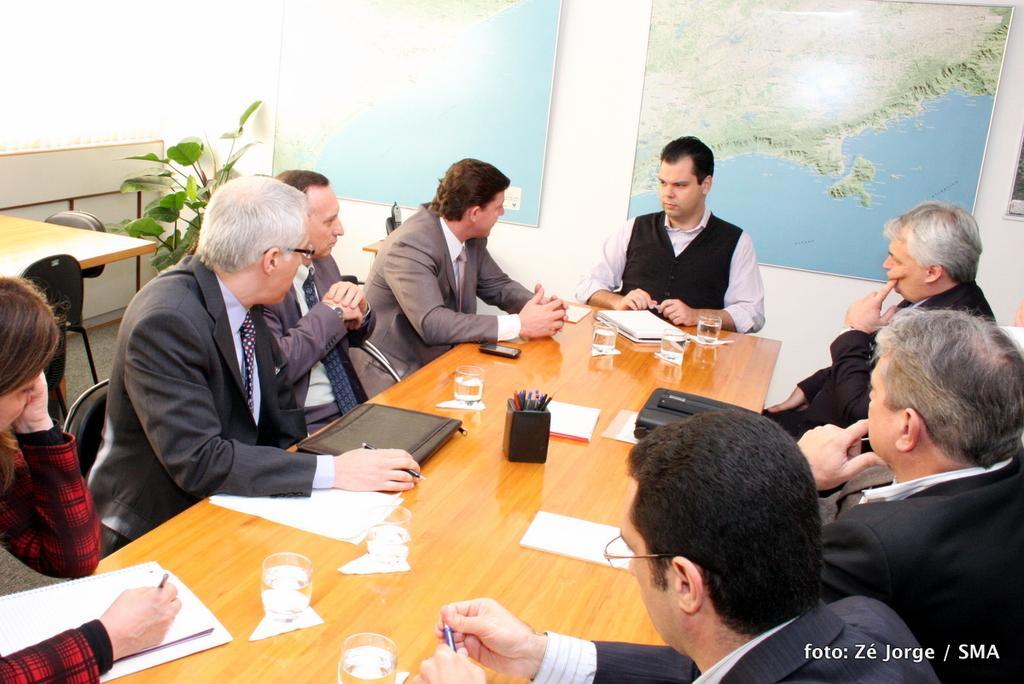Could you give a brief overview of what you see in this image? This is table,on the table this are pen,paper,glass,phone,people are sitting around the table holding pen and in background there is map,there is flower,there is chair. 